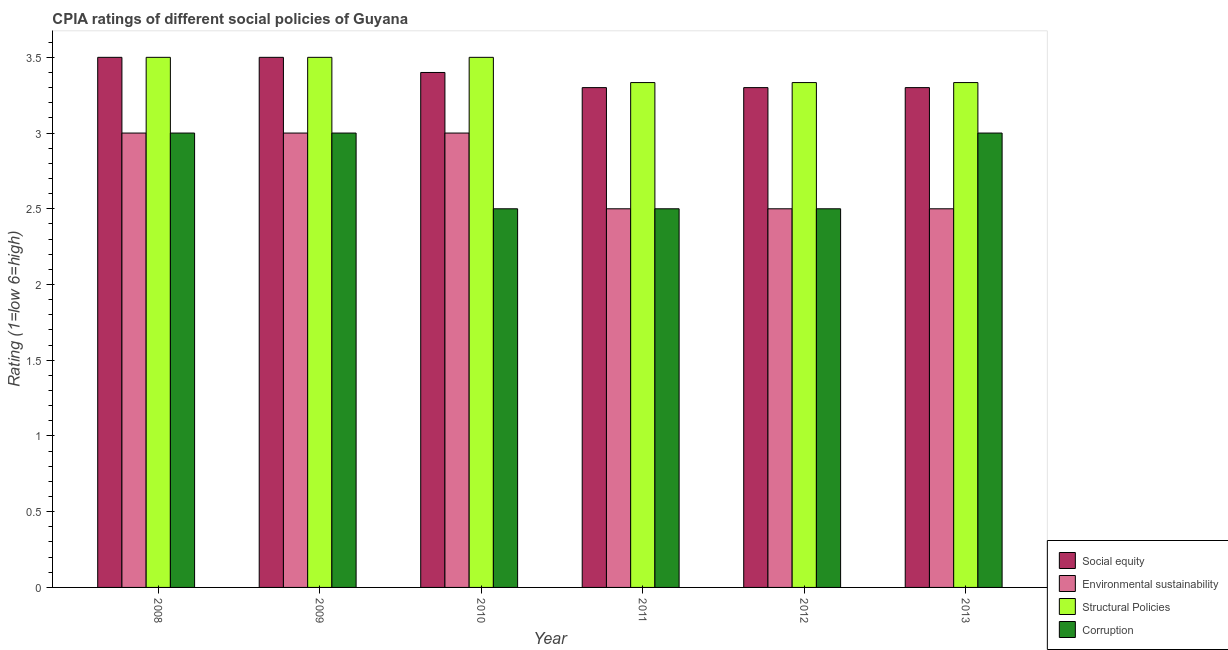How many groups of bars are there?
Offer a very short reply. 6. Are the number of bars per tick equal to the number of legend labels?
Keep it short and to the point. Yes. Are the number of bars on each tick of the X-axis equal?
Your answer should be compact. Yes. What is the label of the 3rd group of bars from the left?
Give a very brief answer. 2010. What is the cpia rating of environmental sustainability in 2013?
Provide a short and direct response. 2.5. Across all years, what is the maximum cpia rating of corruption?
Provide a succinct answer. 3. Across all years, what is the minimum cpia rating of social equity?
Your answer should be compact. 3.3. In which year was the cpia rating of environmental sustainability minimum?
Make the answer very short. 2011. What is the total cpia rating of social equity in the graph?
Your response must be concise. 20.3. What is the difference between the cpia rating of structural policies in 2012 and the cpia rating of corruption in 2013?
Your answer should be compact. 0. What is the average cpia rating of environmental sustainability per year?
Make the answer very short. 2.75. In the year 2010, what is the difference between the cpia rating of corruption and cpia rating of social equity?
Your answer should be very brief. 0. What is the ratio of the cpia rating of environmental sustainability in 2009 to that in 2012?
Keep it short and to the point. 1.2. Is the cpia rating of corruption in 2010 less than that in 2013?
Your answer should be compact. Yes. What is the difference between the highest and the second highest cpia rating of structural policies?
Provide a succinct answer. 0. What is the difference between the highest and the lowest cpia rating of environmental sustainability?
Offer a terse response. 0.5. Is it the case that in every year, the sum of the cpia rating of structural policies and cpia rating of environmental sustainability is greater than the sum of cpia rating of corruption and cpia rating of social equity?
Your response must be concise. Yes. What does the 4th bar from the left in 2008 represents?
Your response must be concise. Corruption. What does the 3rd bar from the right in 2009 represents?
Your answer should be very brief. Environmental sustainability. How many years are there in the graph?
Your answer should be compact. 6. Does the graph contain any zero values?
Your answer should be compact. No. Does the graph contain grids?
Your response must be concise. No. How many legend labels are there?
Ensure brevity in your answer.  4. What is the title of the graph?
Offer a terse response. CPIA ratings of different social policies of Guyana. Does "Labor Taxes" appear as one of the legend labels in the graph?
Ensure brevity in your answer.  No. What is the label or title of the X-axis?
Provide a short and direct response. Year. What is the Rating (1=low 6=high) in Social equity in 2008?
Keep it short and to the point. 3.5. What is the Rating (1=low 6=high) of Environmental sustainability in 2008?
Give a very brief answer. 3. What is the Rating (1=low 6=high) in Structural Policies in 2008?
Provide a short and direct response. 3.5. What is the Rating (1=low 6=high) in Corruption in 2008?
Your response must be concise. 3. What is the Rating (1=low 6=high) of Corruption in 2009?
Provide a succinct answer. 3. What is the Rating (1=low 6=high) in Environmental sustainability in 2010?
Give a very brief answer. 3. What is the Rating (1=low 6=high) of Structural Policies in 2010?
Offer a terse response. 3.5. What is the Rating (1=low 6=high) of Corruption in 2010?
Your response must be concise. 2.5. What is the Rating (1=low 6=high) in Environmental sustainability in 2011?
Make the answer very short. 2.5. What is the Rating (1=low 6=high) in Structural Policies in 2011?
Offer a very short reply. 3.33. What is the Rating (1=low 6=high) of Corruption in 2011?
Keep it short and to the point. 2.5. What is the Rating (1=low 6=high) of Environmental sustainability in 2012?
Your response must be concise. 2.5. What is the Rating (1=low 6=high) of Structural Policies in 2012?
Provide a succinct answer. 3.33. What is the Rating (1=low 6=high) of Corruption in 2012?
Provide a short and direct response. 2.5. What is the Rating (1=low 6=high) in Environmental sustainability in 2013?
Your answer should be compact. 2.5. What is the Rating (1=low 6=high) of Structural Policies in 2013?
Provide a short and direct response. 3.33. What is the Rating (1=low 6=high) in Corruption in 2013?
Offer a terse response. 3. Across all years, what is the maximum Rating (1=low 6=high) of Social equity?
Offer a very short reply. 3.5. Across all years, what is the maximum Rating (1=low 6=high) of Environmental sustainability?
Ensure brevity in your answer.  3. Across all years, what is the maximum Rating (1=low 6=high) of Structural Policies?
Provide a short and direct response. 3.5. Across all years, what is the minimum Rating (1=low 6=high) of Environmental sustainability?
Offer a terse response. 2.5. Across all years, what is the minimum Rating (1=low 6=high) in Structural Policies?
Provide a short and direct response. 3.33. Across all years, what is the minimum Rating (1=low 6=high) in Corruption?
Give a very brief answer. 2.5. What is the total Rating (1=low 6=high) in Social equity in the graph?
Keep it short and to the point. 20.3. What is the total Rating (1=low 6=high) of Environmental sustainability in the graph?
Make the answer very short. 16.5. What is the total Rating (1=low 6=high) of Structural Policies in the graph?
Keep it short and to the point. 20.5. What is the total Rating (1=low 6=high) of Corruption in the graph?
Keep it short and to the point. 16.5. What is the difference between the Rating (1=low 6=high) in Environmental sustainability in 2008 and that in 2009?
Your response must be concise. 0. What is the difference between the Rating (1=low 6=high) of Structural Policies in 2008 and that in 2009?
Keep it short and to the point. 0. What is the difference between the Rating (1=low 6=high) of Corruption in 2008 and that in 2009?
Your answer should be very brief. 0. What is the difference between the Rating (1=low 6=high) in Social equity in 2008 and that in 2010?
Offer a terse response. 0.1. What is the difference between the Rating (1=low 6=high) of Corruption in 2008 and that in 2010?
Your response must be concise. 0.5. What is the difference between the Rating (1=low 6=high) of Environmental sustainability in 2008 and that in 2011?
Offer a very short reply. 0.5. What is the difference between the Rating (1=low 6=high) of Social equity in 2008 and that in 2012?
Provide a short and direct response. 0.2. What is the difference between the Rating (1=low 6=high) in Environmental sustainability in 2008 and that in 2012?
Ensure brevity in your answer.  0.5. What is the difference between the Rating (1=low 6=high) in Social equity in 2008 and that in 2013?
Offer a terse response. 0.2. What is the difference between the Rating (1=low 6=high) of Environmental sustainability in 2008 and that in 2013?
Ensure brevity in your answer.  0.5. What is the difference between the Rating (1=low 6=high) in Structural Policies in 2008 and that in 2013?
Offer a very short reply. 0.17. What is the difference between the Rating (1=low 6=high) of Corruption in 2008 and that in 2013?
Provide a short and direct response. 0. What is the difference between the Rating (1=low 6=high) of Environmental sustainability in 2009 and that in 2010?
Keep it short and to the point. 0. What is the difference between the Rating (1=low 6=high) of Corruption in 2009 and that in 2010?
Keep it short and to the point. 0.5. What is the difference between the Rating (1=low 6=high) in Structural Policies in 2009 and that in 2011?
Give a very brief answer. 0.17. What is the difference between the Rating (1=low 6=high) of Social equity in 2009 and that in 2012?
Provide a succinct answer. 0.2. What is the difference between the Rating (1=low 6=high) in Environmental sustainability in 2009 and that in 2012?
Provide a succinct answer. 0.5. What is the difference between the Rating (1=low 6=high) of Structural Policies in 2009 and that in 2012?
Your response must be concise. 0.17. What is the difference between the Rating (1=low 6=high) of Social equity in 2009 and that in 2013?
Provide a succinct answer. 0.2. What is the difference between the Rating (1=low 6=high) of Structural Policies in 2009 and that in 2013?
Your answer should be very brief. 0.17. What is the difference between the Rating (1=low 6=high) in Corruption in 2010 and that in 2011?
Offer a terse response. 0. What is the difference between the Rating (1=low 6=high) in Environmental sustainability in 2010 and that in 2012?
Ensure brevity in your answer.  0.5. What is the difference between the Rating (1=low 6=high) of Structural Policies in 2010 and that in 2012?
Your answer should be very brief. 0.17. What is the difference between the Rating (1=low 6=high) of Corruption in 2010 and that in 2012?
Your answer should be very brief. 0. What is the difference between the Rating (1=low 6=high) of Social equity in 2010 and that in 2013?
Provide a short and direct response. 0.1. What is the difference between the Rating (1=low 6=high) in Environmental sustainability in 2011 and that in 2012?
Ensure brevity in your answer.  0. What is the difference between the Rating (1=low 6=high) in Social equity in 2011 and that in 2013?
Ensure brevity in your answer.  0. What is the difference between the Rating (1=low 6=high) of Environmental sustainability in 2011 and that in 2013?
Make the answer very short. 0. What is the difference between the Rating (1=low 6=high) in Structural Policies in 2011 and that in 2013?
Ensure brevity in your answer.  0. What is the difference between the Rating (1=low 6=high) in Corruption in 2011 and that in 2013?
Ensure brevity in your answer.  -0.5. What is the difference between the Rating (1=low 6=high) of Social equity in 2012 and that in 2013?
Your answer should be compact. 0. What is the difference between the Rating (1=low 6=high) in Structural Policies in 2012 and that in 2013?
Your response must be concise. 0. What is the difference between the Rating (1=low 6=high) of Social equity in 2008 and the Rating (1=low 6=high) of Environmental sustainability in 2009?
Give a very brief answer. 0.5. What is the difference between the Rating (1=low 6=high) of Social equity in 2008 and the Rating (1=low 6=high) of Structural Policies in 2009?
Provide a short and direct response. 0. What is the difference between the Rating (1=low 6=high) of Social equity in 2008 and the Rating (1=low 6=high) of Corruption in 2010?
Offer a very short reply. 1. What is the difference between the Rating (1=low 6=high) in Environmental sustainability in 2008 and the Rating (1=low 6=high) in Corruption in 2010?
Offer a very short reply. 0.5. What is the difference between the Rating (1=low 6=high) in Structural Policies in 2008 and the Rating (1=low 6=high) in Corruption in 2010?
Give a very brief answer. 1. What is the difference between the Rating (1=low 6=high) of Social equity in 2008 and the Rating (1=low 6=high) of Environmental sustainability in 2011?
Offer a very short reply. 1. What is the difference between the Rating (1=low 6=high) in Social equity in 2008 and the Rating (1=low 6=high) in Corruption in 2011?
Ensure brevity in your answer.  1. What is the difference between the Rating (1=low 6=high) in Environmental sustainability in 2008 and the Rating (1=low 6=high) in Structural Policies in 2011?
Your answer should be very brief. -0.33. What is the difference between the Rating (1=low 6=high) in Structural Policies in 2008 and the Rating (1=low 6=high) in Corruption in 2011?
Your answer should be very brief. 1. What is the difference between the Rating (1=low 6=high) in Social equity in 2008 and the Rating (1=low 6=high) in Structural Policies in 2012?
Ensure brevity in your answer.  0.17. What is the difference between the Rating (1=low 6=high) of Social equity in 2008 and the Rating (1=low 6=high) of Corruption in 2012?
Provide a short and direct response. 1. What is the difference between the Rating (1=low 6=high) of Social equity in 2008 and the Rating (1=low 6=high) of Corruption in 2013?
Provide a succinct answer. 0.5. What is the difference between the Rating (1=low 6=high) of Environmental sustainability in 2008 and the Rating (1=low 6=high) of Structural Policies in 2013?
Your answer should be compact. -0.33. What is the difference between the Rating (1=low 6=high) of Structural Policies in 2008 and the Rating (1=low 6=high) of Corruption in 2013?
Ensure brevity in your answer.  0.5. What is the difference between the Rating (1=low 6=high) in Social equity in 2009 and the Rating (1=low 6=high) in Structural Policies in 2010?
Keep it short and to the point. 0. What is the difference between the Rating (1=low 6=high) in Environmental sustainability in 2009 and the Rating (1=low 6=high) in Structural Policies in 2010?
Your answer should be compact. -0.5. What is the difference between the Rating (1=low 6=high) in Structural Policies in 2009 and the Rating (1=low 6=high) in Corruption in 2010?
Your answer should be very brief. 1. What is the difference between the Rating (1=low 6=high) of Social equity in 2009 and the Rating (1=low 6=high) of Environmental sustainability in 2011?
Ensure brevity in your answer.  1. What is the difference between the Rating (1=low 6=high) in Social equity in 2009 and the Rating (1=low 6=high) in Structural Policies in 2011?
Provide a succinct answer. 0.17. What is the difference between the Rating (1=low 6=high) in Social equity in 2009 and the Rating (1=low 6=high) in Corruption in 2011?
Provide a short and direct response. 1. What is the difference between the Rating (1=low 6=high) of Structural Policies in 2009 and the Rating (1=low 6=high) of Corruption in 2011?
Your response must be concise. 1. What is the difference between the Rating (1=low 6=high) of Social equity in 2009 and the Rating (1=low 6=high) of Corruption in 2012?
Offer a terse response. 1. What is the difference between the Rating (1=low 6=high) in Environmental sustainability in 2009 and the Rating (1=low 6=high) in Structural Policies in 2012?
Keep it short and to the point. -0.33. What is the difference between the Rating (1=low 6=high) in Environmental sustainability in 2009 and the Rating (1=low 6=high) in Corruption in 2012?
Ensure brevity in your answer.  0.5. What is the difference between the Rating (1=low 6=high) of Structural Policies in 2009 and the Rating (1=low 6=high) of Corruption in 2012?
Offer a terse response. 1. What is the difference between the Rating (1=low 6=high) in Social equity in 2009 and the Rating (1=low 6=high) in Structural Policies in 2013?
Provide a short and direct response. 0.17. What is the difference between the Rating (1=low 6=high) of Environmental sustainability in 2009 and the Rating (1=low 6=high) of Structural Policies in 2013?
Ensure brevity in your answer.  -0.33. What is the difference between the Rating (1=low 6=high) in Environmental sustainability in 2009 and the Rating (1=low 6=high) in Corruption in 2013?
Your answer should be compact. 0. What is the difference between the Rating (1=low 6=high) of Structural Policies in 2009 and the Rating (1=low 6=high) of Corruption in 2013?
Make the answer very short. 0.5. What is the difference between the Rating (1=low 6=high) in Social equity in 2010 and the Rating (1=low 6=high) in Structural Policies in 2011?
Provide a short and direct response. 0.07. What is the difference between the Rating (1=low 6=high) of Social equity in 2010 and the Rating (1=low 6=high) of Corruption in 2011?
Make the answer very short. 0.9. What is the difference between the Rating (1=low 6=high) of Environmental sustainability in 2010 and the Rating (1=low 6=high) of Corruption in 2011?
Offer a very short reply. 0.5. What is the difference between the Rating (1=low 6=high) in Social equity in 2010 and the Rating (1=low 6=high) in Environmental sustainability in 2012?
Your response must be concise. 0.9. What is the difference between the Rating (1=low 6=high) of Social equity in 2010 and the Rating (1=low 6=high) of Structural Policies in 2012?
Give a very brief answer. 0.07. What is the difference between the Rating (1=low 6=high) in Social equity in 2010 and the Rating (1=low 6=high) in Corruption in 2012?
Your answer should be compact. 0.9. What is the difference between the Rating (1=low 6=high) of Social equity in 2010 and the Rating (1=low 6=high) of Environmental sustainability in 2013?
Provide a short and direct response. 0.9. What is the difference between the Rating (1=low 6=high) in Social equity in 2010 and the Rating (1=low 6=high) in Structural Policies in 2013?
Offer a terse response. 0.07. What is the difference between the Rating (1=low 6=high) in Environmental sustainability in 2010 and the Rating (1=low 6=high) in Structural Policies in 2013?
Your response must be concise. -0.33. What is the difference between the Rating (1=low 6=high) of Environmental sustainability in 2010 and the Rating (1=low 6=high) of Corruption in 2013?
Keep it short and to the point. 0. What is the difference between the Rating (1=low 6=high) of Social equity in 2011 and the Rating (1=low 6=high) of Structural Policies in 2012?
Make the answer very short. -0.03. What is the difference between the Rating (1=low 6=high) of Social equity in 2011 and the Rating (1=low 6=high) of Corruption in 2012?
Your answer should be very brief. 0.8. What is the difference between the Rating (1=low 6=high) in Environmental sustainability in 2011 and the Rating (1=low 6=high) in Corruption in 2012?
Your response must be concise. 0. What is the difference between the Rating (1=low 6=high) of Social equity in 2011 and the Rating (1=low 6=high) of Environmental sustainability in 2013?
Give a very brief answer. 0.8. What is the difference between the Rating (1=low 6=high) of Social equity in 2011 and the Rating (1=low 6=high) of Structural Policies in 2013?
Ensure brevity in your answer.  -0.03. What is the difference between the Rating (1=low 6=high) in Social equity in 2011 and the Rating (1=low 6=high) in Corruption in 2013?
Ensure brevity in your answer.  0.3. What is the difference between the Rating (1=low 6=high) of Environmental sustainability in 2011 and the Rating (1=low 6=high) of Structural Policies in 2013?
Provide a short and direct response. -0.83. What is the difference between the Rating (1=low 6=high) of Social equity in 2012 and the Rating (1=low 6=high) of Environmental sustainability in 2013?
Give a very brief answer. 0.8. What is the difference between the Rating (1=low 6=high) in Social equity in 2012 and the Rating (1=low 6=high) in Structural Policies in 2013?
Provide a short and direct response. -0.03. What is the difference between the Rating (1=low 6=high) in Social equity in 2012 and the Rating (1=low 6=high) in Corruption in 2013?
Offer a very short reply. 0.3. What is the difference between the Rating (1=low 6=high) of Environmental sustainability in 2012 and the Rating (1=low 6=high) of Corruption in 2013?
Your answer should be compact. -0.5. What is the difference between the Rating (1=low 6=high) in Structural Policies in 2012 and the Rating (1=low 6=high) in Corruption in 2013?
Make the answer very short. 0.33. What is the average Rating (1=low 6=high) of Social equity per year?
Your answer should be very brief. 3.38. What is the average Rating (1=low 6=high) in Environmental sustainability per year?
Offer a very short reply. 2.75. What is the average Rating (1=low 6=high) of Structural Policies per year?
Your response must be concise. 3.42. What is the average Rating (1=low 6=high) of Corruption per year?
Give a very brief answer. 2.75. In the year 2008, what is the difference between the Rating (1=low 6=high) in Social equity and Rating (1=low 6=high) in Structural Policies?
Offer a terse response. 0. In the year 2008, what is the difference between the Rating (1=low 6=high) in Environmental sustainability and Rating (1=low 6=high) in Structural Policies?
Your answer should be compact. -0.5. In the year 2008, what is the difference between the Rating (1=low 6=high) of Environmental sustainability and Rating (1=low 6=high) of Corruption?
Your response must be concise. 0. In the year 2008, what is the difference between the Rating (1=low 6=high) in Structural Policies and Rating (1=low 6=high) in Corruption?
Make the answer very short. 0.5. In the year 2009, what is the difference between the Rating (1=low 6=high) of Social equity and Rating (1=low 6=high) of Corruption?
Ensure brevity in your answer.  0.5. In the year 2009, what is the difference between the Rating (1=low 6=high) of Environmental sustainability and Rating (1=low 6=high) of Corruption?
Ensure brevity in your answer.  0. In the year 2009, what is the difference between the Rating (1=low 6=high) in Structural Policies and Rating (1=low 6=high) in Corruption?
Make the answer very short. 0.5. In the year 2010, what is the difference between the Rating (1=low 6=high) of Social equity and Rating (1=low 6=high) of Environmental sustainability?
Provide a short and direct response. 0.4. In the year 2010, what is the difference between the Rating (1=low 6=high) of Structural Policies and Rating (1=low 6=high) of Corruption?
Give a very brief answer. 1. In the year 2011, what is the difference between the Rating (1=low 6=high) in Social equity and Rating (1=low 6=high) in Structural Policies?
Your response must be concise. -0.03. In the year 2011, what is the difference between the Rating (1=low 6=high) of Social equity and Rating (1=low 6=high) of Corruption?
Offer a terse response. 0.8. In the year 2012, what is the difference between the Rating (1=low 6=high) in Social equity and Rating (1=low 6=high) in Structural Policies?
Give a very brief answer. -0.03. In the year 2012, what is the difference between the Rating (1=low 6=high) in Environmental sustainability and Rating (1=low 6=high) in Structural Policies?
Give a very brief answer. -0.83. In the year 2012, what is the difference between the Rating (1=low 6=high) in Environmental sustainability and Rating (1=low 6=high) in Corruption?
Offer a very short reply. 0. In the year 2013, what is the difference between the Rating (1=low 6=high) of Social equity and Rating (1=low 6=high) of Environmental sustainability?
Ensure brevity in your answer.  0.8. In the year 2013, what is the difference between the Rating (1=low 6=high) of Social equity and Rating (1=low 6=high) of Structural Policies?
Your response must be concise. -0.03. In the year 2013, what is the difference between the Rating (1=low 6=high) in Social equity and Rating (1=low 6=high) in Corruption?
Provide a short and direct response. 0.3. In the year 2013, what is the difference between the Rating (1=low 6=high) of Environmental sustainability and Rating (1=low 6=high) of Structural Policies?
Offer a terse response. -0.83. What is the ratio of the Rating (1=low 6=high) of Social equity in 2008 to that in 2009?
Your answer should be very brief. 1. What is the ratio of the Rating (1=low 6=high) in Environmental sustainability in 2008 to that in 2009?
Ensure brevity in your answer.  1. What is the ratio of the Rating (1=low 6=high) in Structural Policies in 2008 to that in 2009?
Make the answer very short. 1. What is the ratio of the Rating (1=low 6=high) in Social equity in 2008 to that in 2010?
Provide a succinct answer. 1.03. What is the ratio of the Rating (1=low 6=high) of Corruption in 2008 to that in 2010?
Offer a terse response. 1.2. What is the ratio of the Rating (1=low 6=high) in Social equity in 2008 to that in 2011?
Your response must be concise. 1.06. What is the ratio of the Rating (1=low 6=high) of Environmental sustainability in 2008 to that in 2011?
Provide a succinct answer. 1.2. What is the ratio of the Rating (1=low 6=high) of Structural Policies in 2008 to that in 2011?
Ensure brevity in your answer.  1.05. What is the ratio of the Rating (1=low 6=high) of Corruption in 2008 to that in 2011?
Your response must be concise. 1.2. What is the ratio of the Rating (1=low 6=high) of Social equity in 2008 to that in 2012?
Provide a short and direct response. 1.06. What is the ratio of the Rating (1=low 6=high) in Corruption in 2008 to that in 2012?
Keep it short and to the point. 1.2. What is the ratio of the Rating (1=low 6=high) of Social equity in 2008 to that in 2013?
Provide a succinct answer. 1.06. What is the ratio of the Rating (1=low 6=high) in Environmental sustainability in 2008 to that in 2013?
Offer a terse response. 1.2. What is the ratio of the Rating (1=low 6=high) of Corruption in 2008 to that in 2013?
Provide a succinct answer. 1. What is the ratio of the Rating (1=low 6=high) in Social equity in 2009 to that in 2010?
Offer a very short reply. 1.03. What is the ratio of the Rating (1=low 6=high) of Corruption in 2009 to that in 2010?
Your answer should be very brief. 1.2. What is the ratio of the Rating (1=low 6=high) of Social equity in 2009 to that in 2011?
Your answer should be very brief. 1.06. What is the ratio of the Rating (1=low 6=high) of Corruption in 2009 to that in 2011?
Provide a succinct answer. 1.2. What is the ratio of the Rating (1=low 6=high) in Social equity in 2009 to that in 2012?
Your answer should be compact. 1.06. What is the ratio of the Rating (1=low 6=high) of Environmental sustainability in 2009 to that in 2012?
Ensure brevity in your answer.  1.2. What is the ratio of the Rating (1=low 6=high) of Corruption in 2009 to that in 2012?
Ensure brevity in your answer.  1.2. What is the ratio of the Rating (1=low 6=high) in Social equity in 2009 to that in 2013?
Offer a terse response. 1.06. What is the ratio of the Rating (1=low 6=high) in Social equity in 2010 to that in 2011?
Provide a succinct answer. 1.03. What is the ratio of the Rating (1=low 6=high) of Structural Policies in 2010 to that in 2011?
Provide a succinct answer. 1.05. What is the ratio of the Rating (1=low 6=high) in Social equity in 2010 to that in 2012?
Your response must be concise. 1.03. What is the ratio of the Rating (1=low 6=high) of Environmental sustainability in 2010 to that in 2012?
Make the answer very short. 1.2. What is the ratio of the Rating (1=low 6=high) of Corruption in 2010 to that in 2012?
Offer a terse response. 1. What is the ratio of the Rating (1=low 6=high) of Social equity in 2010 to that in 2013?
Offer a very short reply. 1.03. What is the ratio of the Rating (1=low 6=high) of Structural Policies in 2010 to that in 2013?
Your answer should be very brief. 1.05. What is the ratio of the Rating (1=low 6=high) in Corruption in 2011 to that in 2012?
Your answer should be compact. 1. What is the ratio of the Rating (1=low 6=high) in Environmental sustainability in 2011 to that in 2013?
Your answer should be compact. 1. What is the ratio of the Rating (1=low 6=high) of Structural Policies in 2011 to that in 2013?
Provide a succinct answer. 1. What is the ratio of the Rating (1=low 6=high) in Structural Policies in 2012 to that in 2013?
Your answer should be compact. 1. What is the difference between the highest and the second highest Rating (1=low 6=high) of Environmental sustainability?
Provide a short and direct response. 0. What is the difference between the highest and the second highest Rating (1=low 6=high) in Structural Policies?
Ensure brevity in your answer.  0. What is the difference between the highest and the lowest Rating (1=low 6=high) in Structural Policies?
Ensure brevity in your answer.  0.17. 